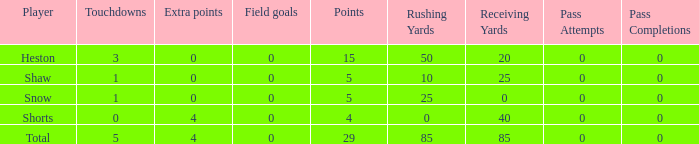What is the total number of field goals a player had when there were more than 0 extra points and there were 5 touchdowns? 1.0. 